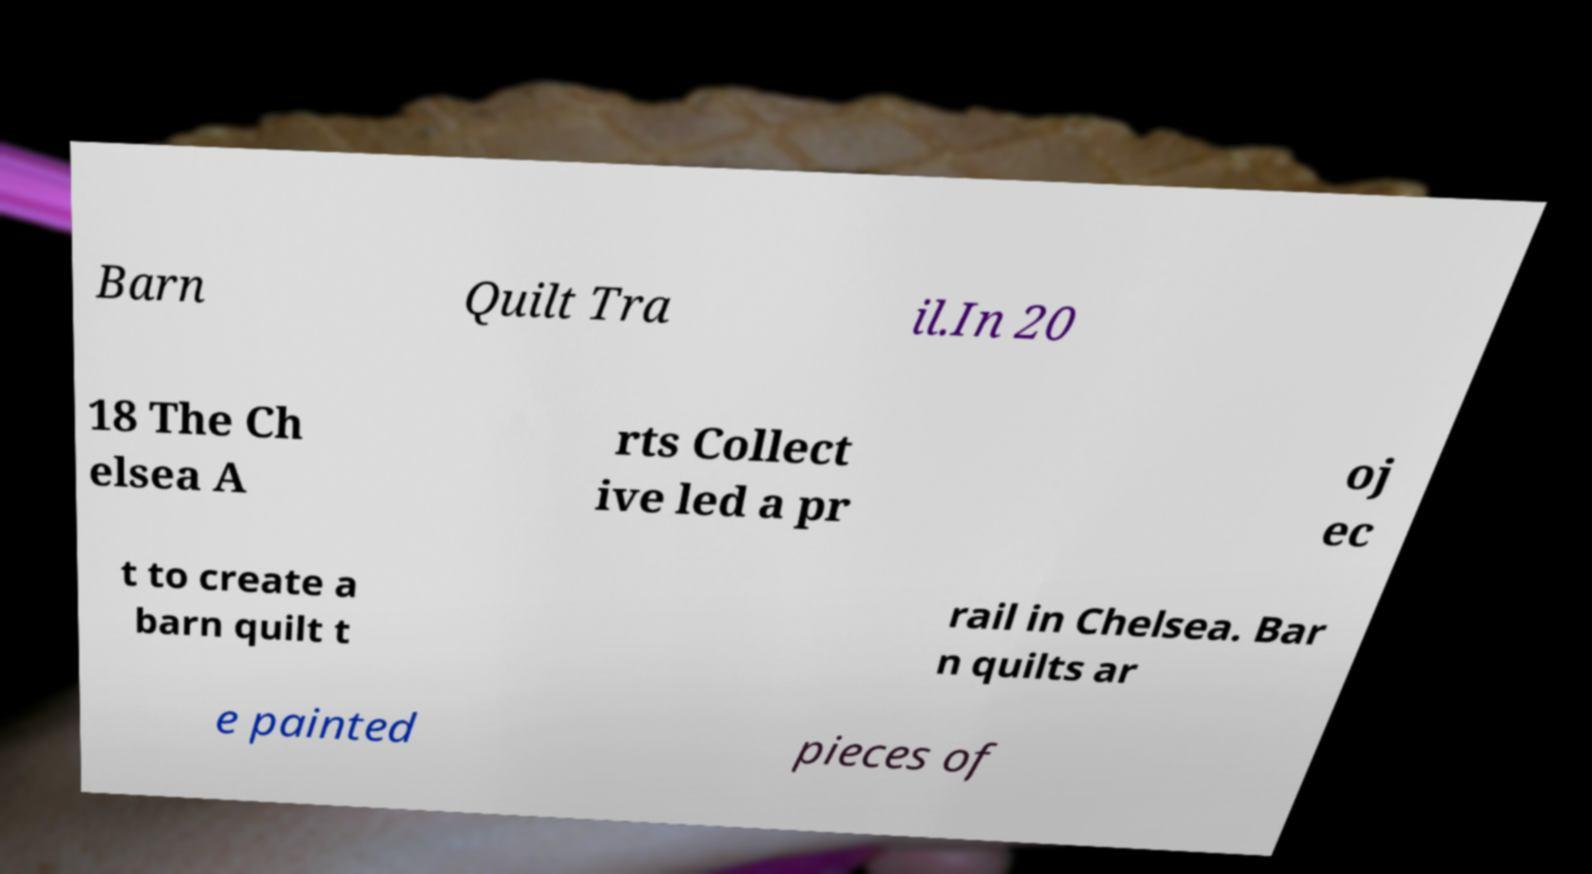Could you assist in decoding the text presented in this image and type it out clearly? Barn Quilt Tra il.In 20 18 The Ch elsea A rts Collect ive led a pr oj ec t to create a barn quilt t rail in Chelsea. Bar n quilts ar e painted pieces of 